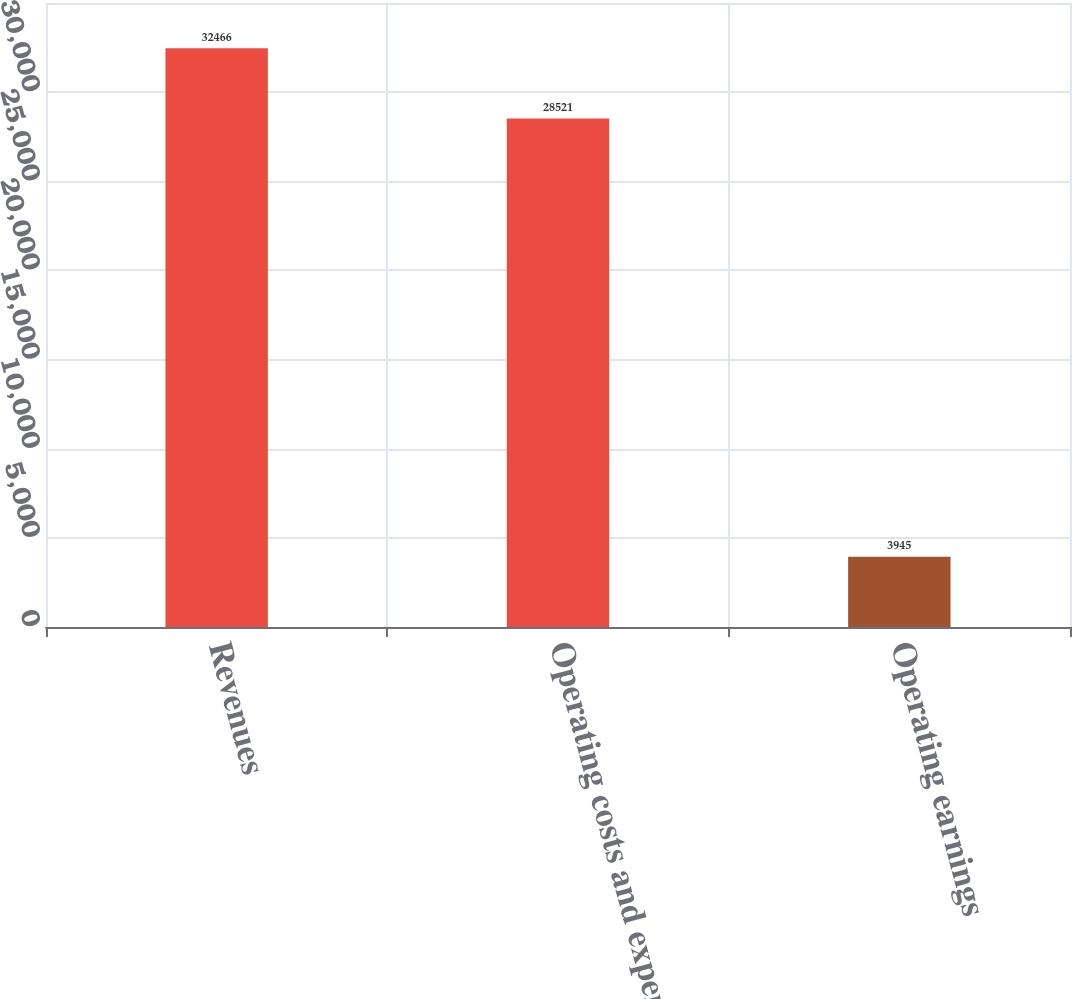Convert chart to OTSL. <chart><loc_0><loc_0><loc_500><loc_500><bar_chart><fcel>Revenues<fcel>Operating costs and expenses<fcel>Operating earnings<nl><fcel>32466<fcel>28521<fcel>3945<nl></chart> 